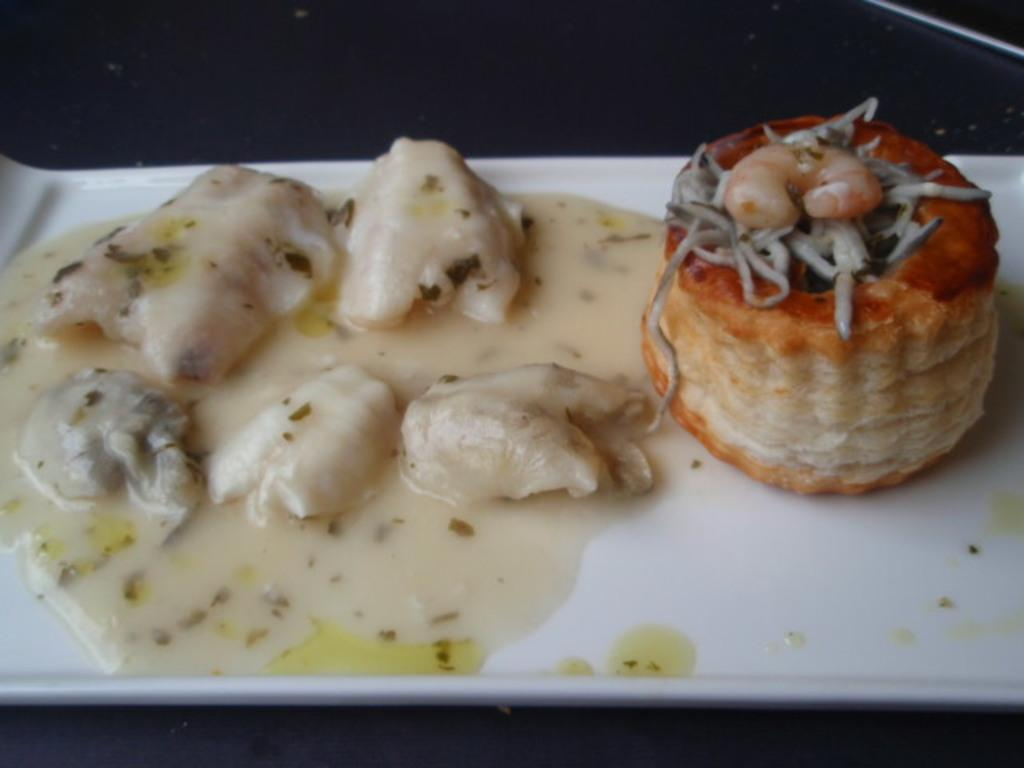What types of items are visible in the image? There are food items in the image. On what is the food placed? The food items are on a white-colored plate. What historical event is depicted in the image? There is no historical event depicted in the image; it features food items on a white-colored plate. What type of clothing is visible in the image? There is no clothing visible in the image; it features food items on a white-colored plate. 